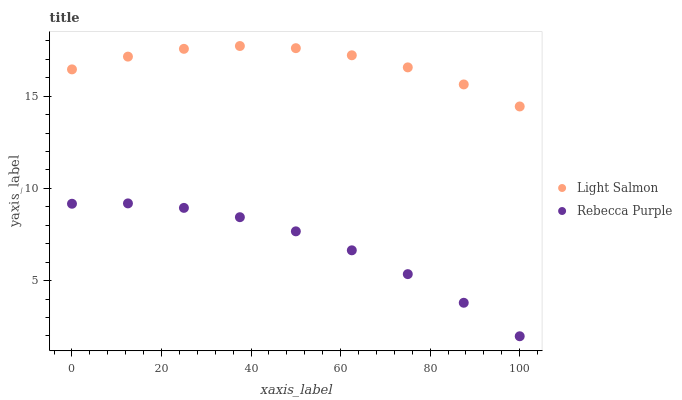Does Rebecca Purple have the minimum area under the curve?
Answer yes or no. Yes. Does Light Salmon have the maximum area under the curve?
Answer yes or no. Yes. Does Rebecca Purple have the maximum area under the curve?
Answer yes or no. No. Is Rebecca Purple the smoothest?
Answer yes or no. Yes. Is Light Salmon the roughest?
Answer yes or no. Yes. Is Rebecca Purple the roughest?
Answer yes or no. No. Does Rebecca Purple have the lowest value?
Answer yes or no. Yes. Does Light Salmon have the highest value?
Answer yes or no. Yes. Does Rebecca Purple have the highest value?
Answer yes or no. No. Is Rebecca Purple less than Light Salmon?
Answer yes or no. Yes. Is Light Salmon greater than Rebecca Purple?
Answer yes or no. Yes. Does Rebecca Purple intersect Light Salmon?
Answer yes or no. No. 